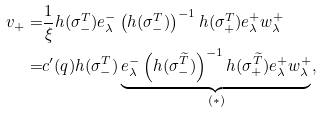Convert formula to latex. <formula><loc_0><loc_0><loc_500><loc_500>v _ { + } = & \frac { 1 } { \xi } h ( \sigma ^ { T } _ { - } ) e ^ { - } _ { \lambda } \left ( h ( \sigma ^ { T } _ { - } ) \right ) ^ { - 1 } h ( \sigma ^ { T } _ { + } ) e ^ { + } _ { \lambda } w _ { \lambda } ^ { + } \\ = & c ^ { \prime } ( q ) h ( \sigma ^ { T } _ { - } ) \underbrace { e ^ { - } _ { \lambda } \left ( h ( \sigma ^ { \widetilde { T } } _ { - } ) \right ) ^ { - 1 } h ( \sigma ^ { \widetilde { T } } _ { + } ) e ^ { + } _ { \lambda } w _ { \lambda } ^ { + } } _ { ( \ast ) } ,</formula> 